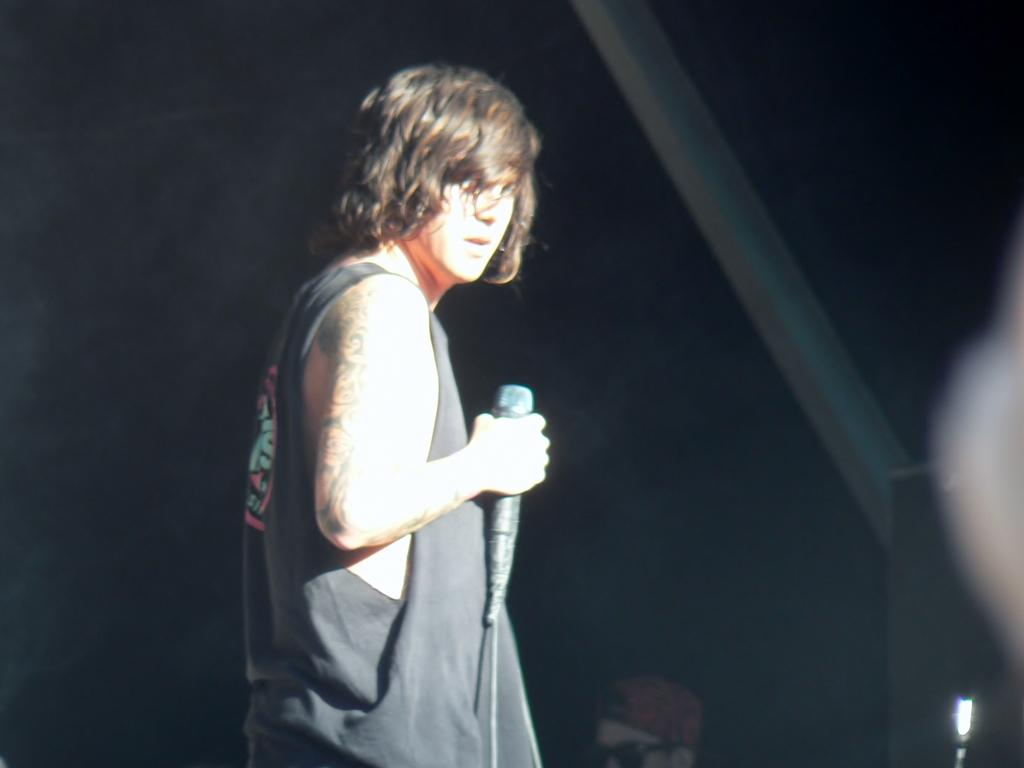What is the main subject of the image? The main subject of the image is a man standing in the middle of the image. What is the man holding in the image? The man is holding a microphone. What type of boundary is visible in the image? There is no boundary present in the image. What type of plough is the man using in the image? There is no plough present in the image. 